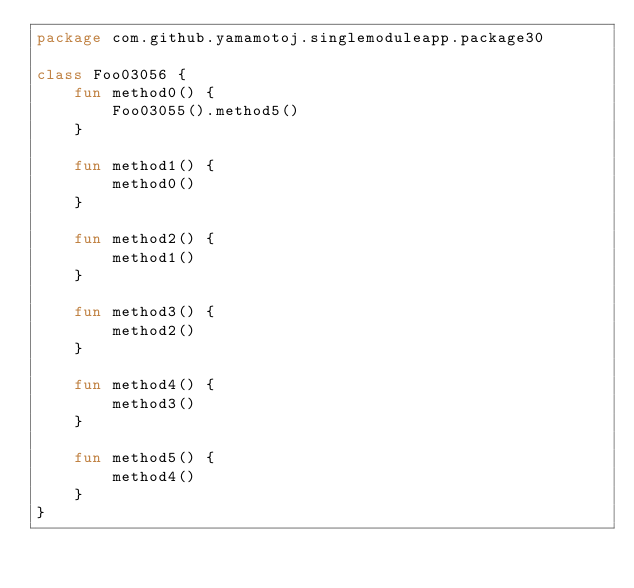<code> <loc_0><loc_0><loc_500><loc_500><_Kotlin_>package com.github.yamamotoj.singlemoduleapp.package30

class Foo03056 {
    fun method0() {
        Foo03055().method5()
    }

    fun method1() {
        method0()
    }

    fun method2() {
        method1()
    }

    fun method3() {
        method2()
    }

    fun method4() {
        method3()
    }

    fun method5() {
        method4()
    }
}
</code> 